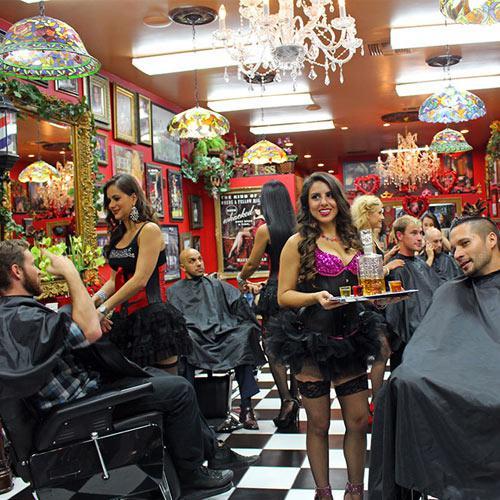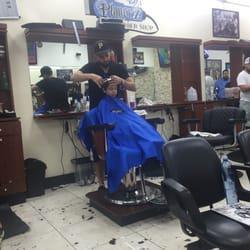The first image is the image on the left, the second image is the image on the right. For the images displayed, is the sentence "In at least one image there are at least three men with black hair getting there hair cut." factually correct? Answer yes or no. No. The first image is the image on the left, the second image is the image on the right. Assess this claim about the two images: "The left image features a row of male customers sitting and wearing black smocks, with someone standing behind them.". Correct or not? Answer yes or no. No. 